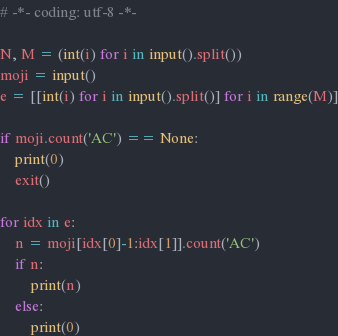<code> <loc_0><loc_0><loc_500><loc_500><_Python_># -*- coding: utf-8 -*-

N, M = (int(i) for i in input().split())
moji = input()
e = [[int(i) for i in input().split()] for i in range(M)]

if moji.count('AC') == None:
    print(0)
    exit()

for idx in e:
    n = moji[idx[0]-1:idx[1]].count('AC')
    if n:
        print(n)
    else:
        print(0)</code> 